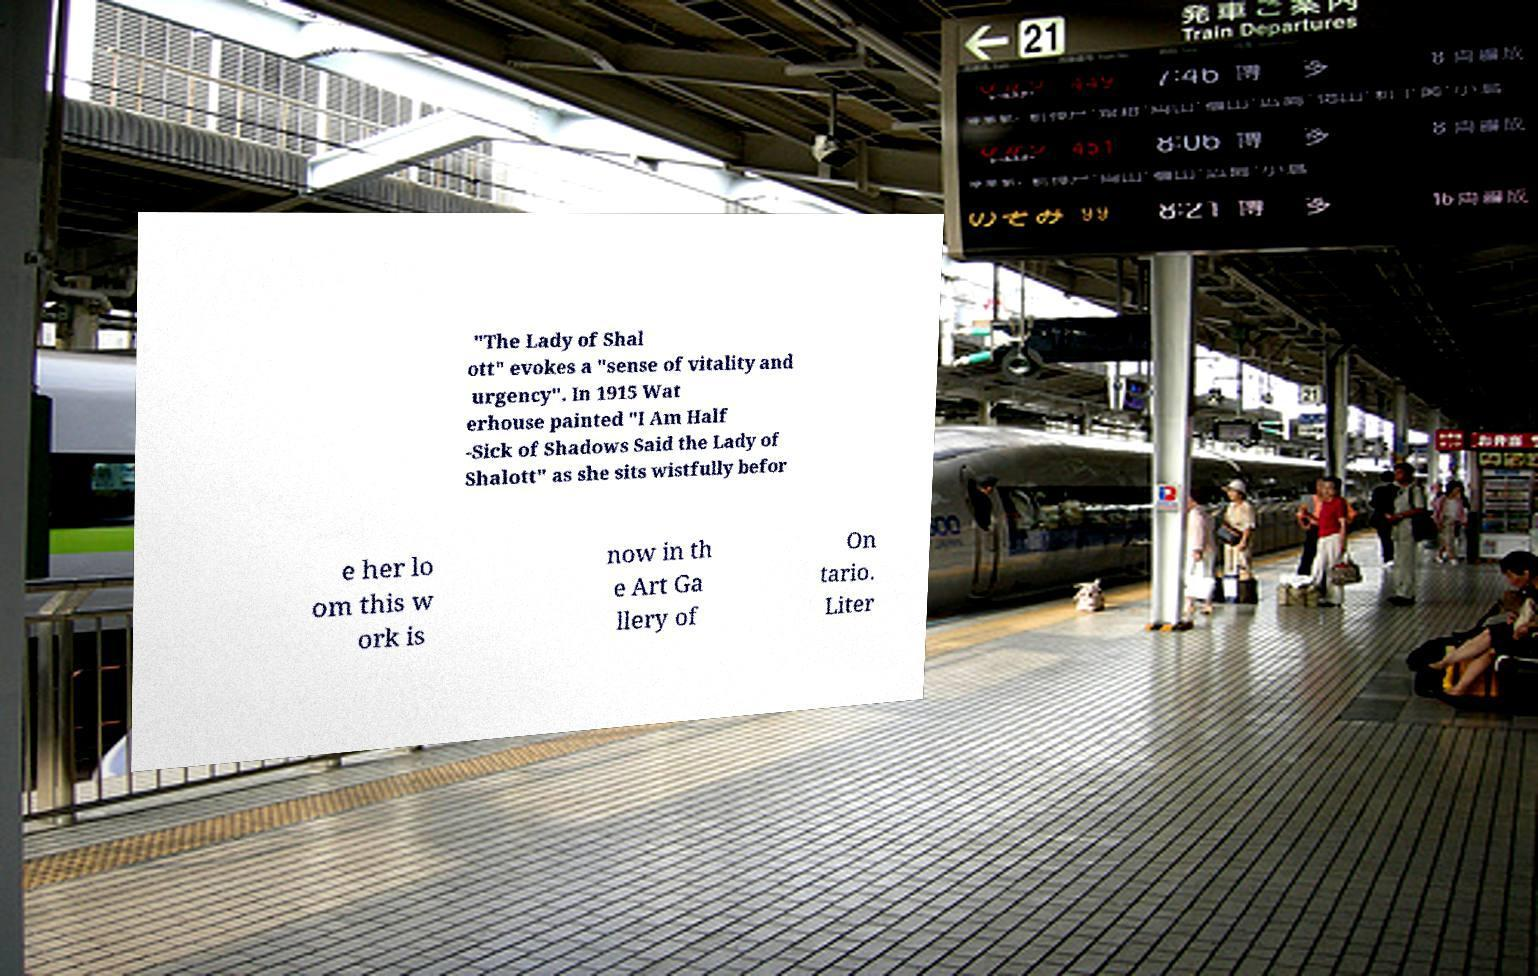There's text embedded in this image that I need extracted. Can you transcribe it verbatim? "The Lady of Shal ott" evokes a "sense of vitality and urgency". In 1915 Wat erhouse painted "I Am Half -Sick of Shadows Said the Lady of Shalott" as she sits wistfully befor e her lo om this w ork is now in th e Art Ga llery of On tario. Liter 